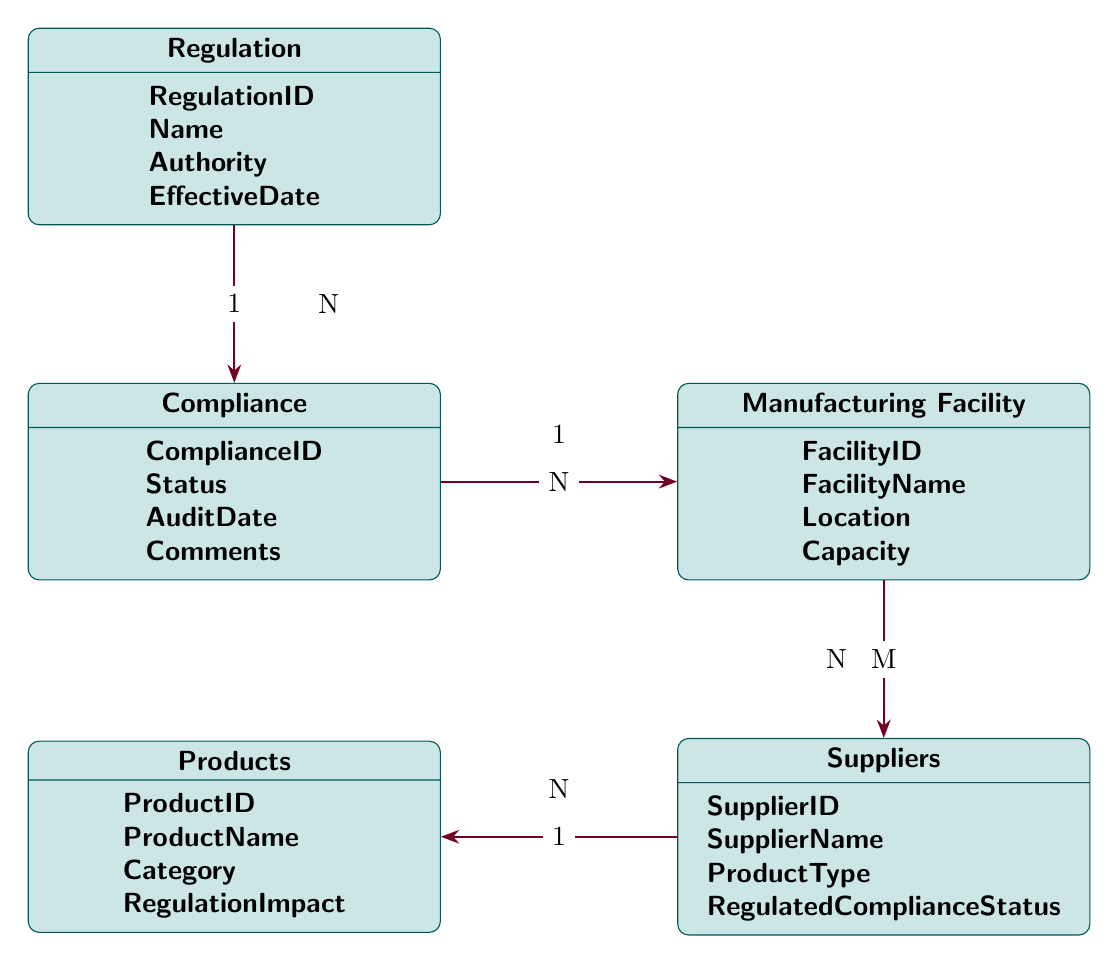What is the primary key for the Regulation entity? The primary key for the Regulation entity is RegulationID, which uniquely identifies each record in that entity.
Answer: RegulationID How many attributes does the Suppliers entity have? The Suppliers entity has four attributes: SupplierID, SupplierName, ProductType, and RegulatedComplianceStatus.
Answer: 4 What type of relationship exists between Compliance and Manufacturing Facility? The relationship between Compliance and Manufacturing Facility is Many to One, meaning multiple Compliance records can relate to a single Manufacturing Facility record.
Answer: Many to One How many entities are there in total in the diagram? There are five entities present in the diagram: Regulation, Compliance, Manufacturing Facility, Suppliers, and Products.
Answer: 5 What is the foreign key used in the relationship between Regulation and Compliance? The foreign key in the relationship between Regulation and Compliance is RegulationID, which links Compliance entries to their respective Regulation entries.
Answer: RegulationID Which entity has the attribute named "RegulationImpact"? The entity that has the attribute named "RegulationImpact" is Products. This attribute describes how a regulation affects the product.
Answer: Products What kind of relationship is there between Suppliers and Products? The relationship between Suppliers and Products is One to Many, meaning a single Supplier can provide multiple Products, while each Product comes from one Supplier.
Answer: One to Many What is the maximum number of Compliance entries that can link to one Regulation entry? In the diagram, each Regulation can link to multiple Compliance entries, indicating an unrestricted number represented as N in the diagram.
Answer: N How many Manufacturing Facilities can be associated with a single Compliance record? Each Compliance record can be associated with one Manufacturing Facility, indicating a single entry in that case based on the Many to One relationship.
Answer: 1 